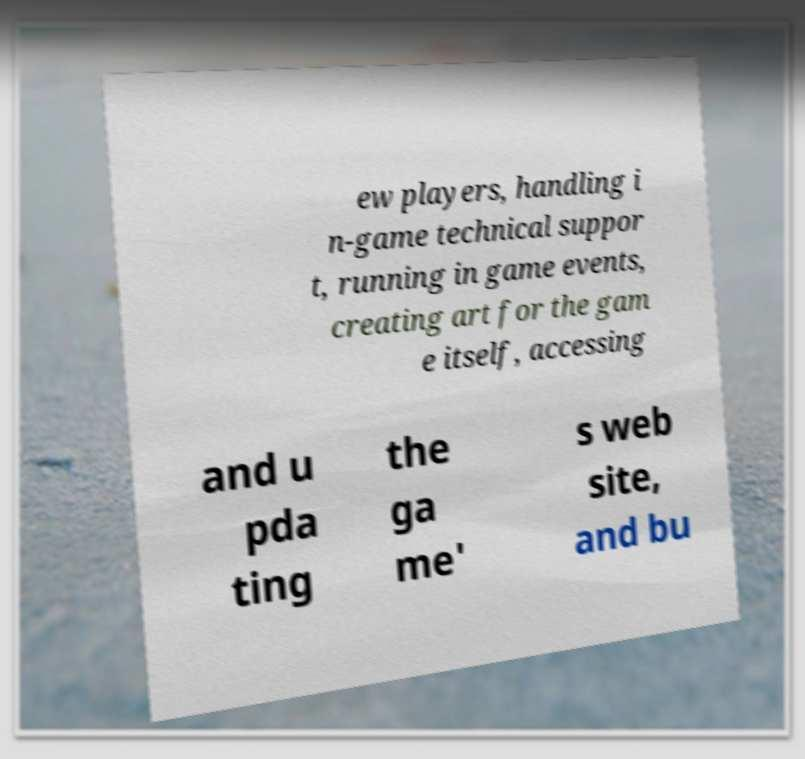Can you accurately transcribe the text from the provided image for me? ew players, handling i n-game technical suppor t, running in game events, creating art for the gam e itself, accessing and u pda ting the ga me' s web site, and bu 